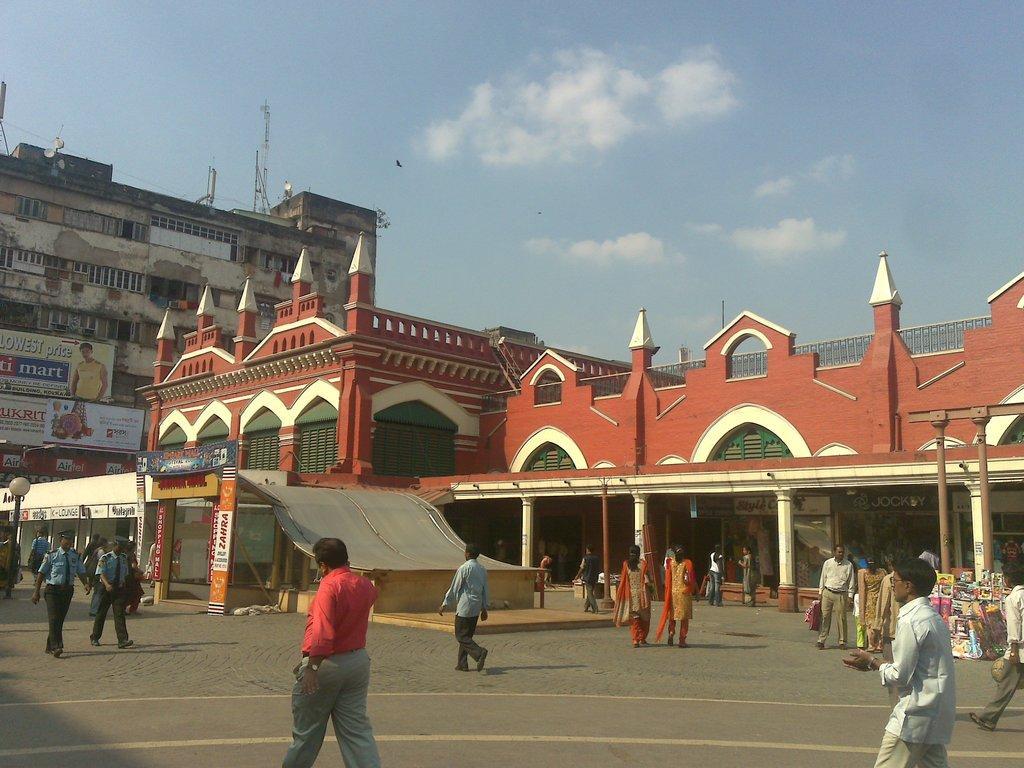How would you summarize this image in a sentence or two? In this image in the front there are group of persons standing and walking. In the background there are buildings and there are boards with some text written on it and the sky is cloudy. 